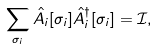<formula> <loc_0><loc_0><loc_500><loc_500>\sum _ { \sigma _ { i } } \hat { A } _ { i } [ \sigma _ { i } ] \hat { A } _ { i } ^ { \dag } [ \sigma _ { i } ] = \mathcal { I } ,</formula> 